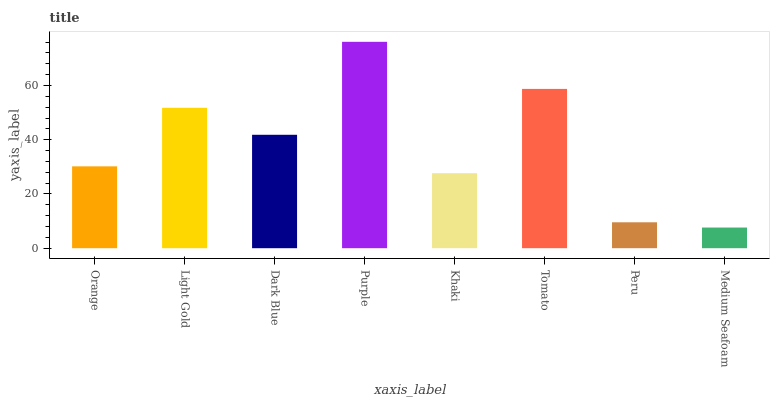Is Medium Seafoam the minimum?
Answer yes or no. Yes. Is Purple the maximum?
Answer yes or no. Yes. Is Light Gold the minimum?
Answer yes or no. No. Is Light Gold the maximum?
Answer yes or no. No. Is Light Gold greater than Orange?
Answer yes or no. Yes. Is Orange less than Light Gold?
Answer yes or no. Yes. Is Orange greater than Light Gold?
Answer yes or no. No. Is Light Gold less than Orange?
Answer yes or no. No. Is Dark Blue the high median?
Answer yes or no. Yes. Is Orange the low median?
Answer yes or no. Yes. Is Light Gold the high median?
Answer yes or no. No. Is Khaki the low median?
Answer yes or no. No. 